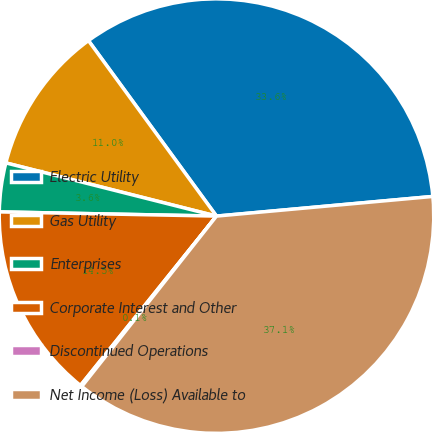<chart> <loc_0><loc_0><loc_500><loc_500><pie_chart><fcel>Electric Utility<fcel>Gas Utility<fcel>Enterprises<fcel>Corporate Interest and Other<fcel>Discontinued Operations<fcel>Net Income (Loss) Available to<nl><fcel>33.59%<fcel>11.03%<fcel>3.63%<fcel>14.54%<fcel>0.12%<fcel>37.09%<nl></chart> 